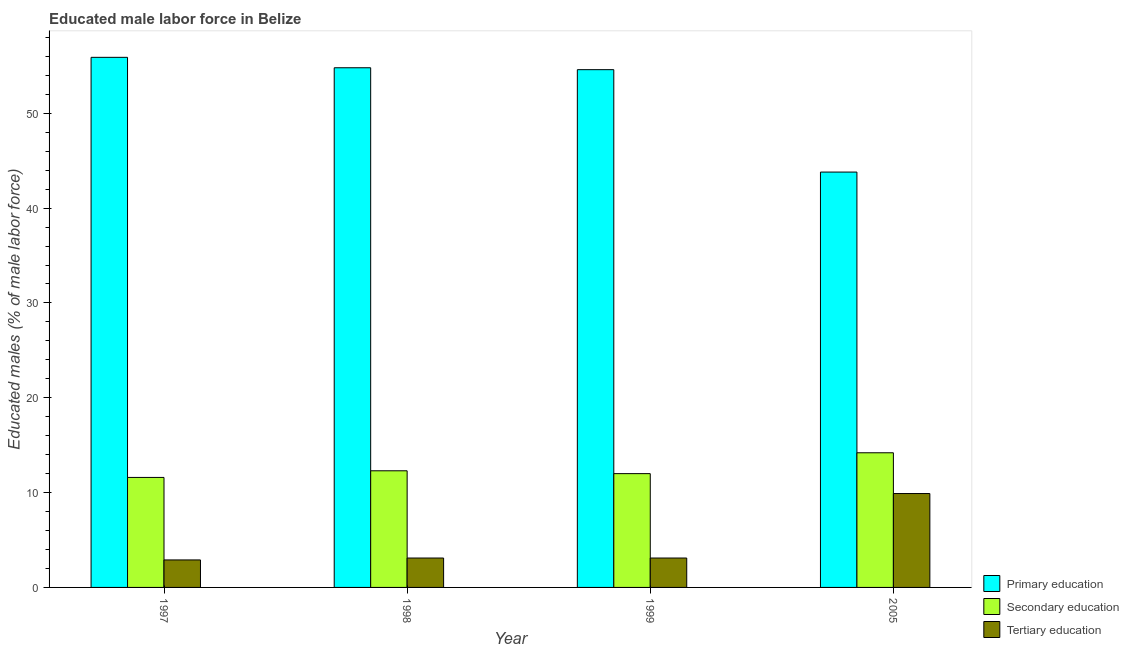How many different coloured bars are there?
Your answer should be very brief. 3. How many bars are there on the 2nd tick from the left?
Your answer should be compact. 3. How many bars are there on the 1st tick from the right?
Your response must be concise. 3. What is the label of the 3rd group of bars from the left?
Provide a succinct answer. 1999. What is the percentage of male labor force who received primary education in 1998?
Ensure brevity in your answer.  54.8. Across all years, what is the maximum percentage of male labor force who received secondary education?
Give a very brief answer. 14.2. Across all years, what is the minimum percentage of male labor force who received secondary education?
Offer a terse response. 11.6. In which year was the percentage of male labor force who received tertiary education maximum?
Give a very brief answer. 2005. What is the total percentage of male labor force who received secondary education in the graph?
Your response must be concise. 50.1. What is the difference between the percentage of male labor force who received primary education in 1998 and that in 1999?
Keep it short and to the point. 0.2. What is the difference between the percentage of male labor force who received tertiary education in 1997 and the percentage of male labor force who received primary education in 2005?
Provide a succinct answer. -7. What is the average percentage of male labor force who received tertiary education per year?
Provide a succinct answer. 4.75. In how many years, is the percentage of male labor force who received tertiary education greater than 16 %?
Provide a succinct answer. 0. What is the ratio of the percentage of male labor force who received secondary education in 1997 to that in 2005?
Make the answer very short. 0.82. Is the percentage of male labor force who received tertiary education in 1999 less than that in 2005?
Offer a terse response. Yes. Is the difference between the percentage of male labor force who received secondary education in 1998 and 1999 greater than the difference between the percentage of male labor force who received primary education in 1998 and 1999?
Ensure brevity in your answer.  No. What is the difference between the highest and the second highest percentage of male labor force who received tertiary education?
Your answer should be compact. 6.8. What is the difference between the highest and the lowest percentage of male labor force who received tertiary education?
Your answer should be compact. 7. In how many years, is the percentage of male labor force who received primary education greater than the average percentage of male labor force who received primary education taken over all years?
Your response must be concise. 3. Is the sum of the percentage of male labor force who received primary education in 1998 and 1999 greater than the maximum percentage of male labor force who received tertiary education across all years?
Make the answer very short. Yes. What does the 2nd bar from the left in 1997 represents?
Your answer should be very brief. Secondary education. What does the 1st bar from the right in 2005 represents?
Make the answer very short. Tertiary education. How many bars are there?
Offer a terse response. 12. Are all the bars in the graph horizontal?
Provide a short and direct response. No. Does the graph contain grids?
Ensure brevity in your answer.  No. How many legend labels are there?
Offer a terse response. 3. How are the legend labels stacked?
Your answer should be compact. Vertical. What is the title of the graph?
Your answer should be very brief. Educated male labor force in Belize. What is the label or title of the X-axis?
Give a very brief answer. Year. What is the label or title of the Y-axis?
Offer a very short reply. Educated males (% of male labor force). What is the Educated males (% of male labor force) in Primary education in 1997?
Your response must be concise. 55.9. What is the Educated males (% of male labor force) in Secondary education in 1997?
Offer a very short reply. 11.6. What is the Educated males (% of male labor force) in Tertiary education in 1997?
Offer a terse response. 2.9. What is the Educated males (% of male labor force) of Primary education in 1998?
Offer a terse response. 54.8. What is the Educated males (% of male labor force) in Secondary education in 1998?
Keep it short and to the point. 12.3. What is the Educated males (% of male labor force) in Tertiary education in 1998?
Provide a succinct answer. 3.1. What is the Educated males (% of male labor force) of Primary education in 1999?
Give a very brief answer. 54.6. What is the Educated males (% of male labor force) in Secondary education in 1999?
Your answer should be very brief. 12. What is the Educated males (% of male labor force) of Tertiary education in 1999?
Ensure brevity in your answer.  3.1. What is the Educated males (% of male labor force) in Primary education in 2005?
Keep it short and to the point. 43.8. What is the Educated males (% of male labor force) in Secondary education in 2005?
Provide a succinct answer. 14.2. What is the Educated males (% of male labor force) of Tertiary education in 2005?
Provide a succinct answer. 9.9. Across all years, what is the maximum Educated males (% of male labor force) of Primary education?
Your answer should be very brief. 55.9. Across all years, what is the maximum Educated males (% of male labor force) of Secondary education?
Offer a terse response. 14.2. Across all years, what is the maximum Educated males (% of male labor force) of Tertiary education?
Offer a terse response. 9.9. Across all years, what is the minimum Educated males (% of male labor force) of Primary education?
Offer a terse response. 43.8. Across all years, what is the minimum Educated males (% of male labor force) in Secondary education?
Keep it short and to the point. 11.6. Across all years, what is the minimum Educated males (% of male labor force) in Tertiary education?
Provide a short and direct response. 2.9. What is the total Educated males (% of male labor force) of Primary education in the graph?
Your response must be concise. 209.1. What is the total Educated males (% of male labor force) in Secondary education in the graph?
Your response must be concise. 50.1. What is the total Educated males (% of male labor force) of Tertiary education in the graph?
Make the answer very short. 19. What is the difference between the Educated males (% of male labor force) of Primary education in 1997 and that in 1998?
Make the answer very short. 1.1. What is the difference between the Educated males (% of male labor force) in Primary education in 1997 and that in 1999?
Offer a very short reply. 1.3. What is the difference between the Educated males (% of male labor force) of Secondary education in 1997 and that in 1999?
Offer a very short reply. -0.4. What is the difference between the Educated males (% of male labor force) of Tertiary education in 1997 and that in 1999?
Make the answer very short. -0.2. What is the difference between the Educated males (% of male labor force) in Tertiary education in 1997 and that in 2005?
Your answer should be compact. -7. What is the difference between the Educated males (% of male labor force) of Secondary education in 1998 and that in 1999?
Offer a terse response. 0.3. What is the difference between the Educated males (% of male labor force) in Secondary education in 1998 and that in 2005?
Offer a very short reply. -1.9. What is the difference between the Educated males (% of male labor force) in Primary education in 1999 and that in 2005?
Offer a very short reply. 10.8. What is the difference between the Educated males (% of male labor force) in Secondary education in 1999 and that in 2005?
Ensure brevity in your answer.  -2.2. What is the difference between the Educated males (% of male labor force) in Primary education in 1997 and the Educated males (% of male labor force) in Secondary education in 1998?
Your answer should be very brief. 43.6. What is the difference between the Educated males (% of male labor force) in Primary education in 1997 and the Educated males (% of male labor force) in Tertiary education in 1998?
Provide a short and direct response. 52.8. What is the difference between the Educated males (% of male labor force) in Secondary education in 1997 and the Educated males (% of male labor force) in Tertiary education in 1998?
Ensure brevity in your answer.  8.5. What is the difference between the Educated males (% of male labor force) of Primary education in 1997 and the Educated males (% of male labor force) of Secondary education in 1999?
Provide a short and direct response. 43.9. What is the difference between the Educated males (% of male labor force) of Primary education in 1997 and the Educated males (% of male labor force) of Tertiary education in 1999?
Offer a terse response. 52.8. What is the difference between the Educated males (% of male labor force) in Secondary education in 1997 and the Educated males (% of male labor force) in Tertiary education in 1999?
Your answer should be compact. 8.5. What is the difference between the Educated males (% of male labor force) in Primary education in 1997 and the Educated males (% of male labor force) in Secondary education in 2005?
Your answer should be compact. 41.7. What is the difference between the Educated males (% of male labor force) in Secondary education in 1997 and the Educated males (% of male labor force) in Tertiary education in 2005?
Offer a terse response. 1.7. What is the difference between the Educated males (% of male labor force) of Primary education in 1998 and the Educated males (% of male labor force) of Secondary education in 1999?
Your response must be concise. 42.8. What is the difference between the Educated males (% of male labor force) of Primary education in 1998 and the Educated males (% of male labor force) of Tertiary education in 1999?
Ensure brevity in your answer.  51.7. What is the difference between the Educated males (% of male labor force) in Primary education in 1998 and the Educated males (% of male labor force) in Secondary education in 2005?
Give a very brief answer. 40.6. What is the difference between the Educated males (% of male labor force) of Primary education in 1998 and the Educated males (% of male labor force) of Tertiary education in 2005?
Your response must be concise. 44.9. What is the difference between the Educated males (% of male labor force) of Secondary education in 1998 and the Educated males (% of male labor force) of Tertiary education in 2005?
Give a very brief answer. 2.4. What is the difference between the Educated males (% of male labor force) in Primary education in 1999 and the Educated males (% of male labor force) in Secondary education in 2005?
Offer a terse response. 40.4. What is the difference between the Educated males (% of male labor force) in Primary education in 1999 and the Educated males (% of male labor force) in Tertiary education in 2005?
Make the answer very short. 44.7. What is the difference between the Educated males (% of male labor force) in Secondary education in 1999 and the Educated males (% of male labor force) in Tertiary education in 2005?
Your answer should be compact. 2.1. What is the average Educated males (% of male labor force) in Primary education per year?
Provide a succinct answer. 52.27. What is the average Educated males (% of male labor force) in Secondary education per year?
Provide a succinct answer. 12.53. What is the average Educated males (% of male labor force) in Tertiary education per year?
Keep it short and to the point. 4.75. In the year 1997, what is the difference between the Educated males (% of male labor force) of Primary education and Educated males (% of male labor force) of Secondary education?
Provide a succinct answer. 44.3. In the year 1997, what is the difference between the Educated males (% of male labor force) of Secondary education and Educated males (% of male labor force) of Tertiary education?
Give a very brief answer. 8.7. In the year 1998, what is the difference between the Educated males (% of male labor force) of Primary education and Educated males (% of male labor force) of Secondary education?
Give a very brief answer. 42.5. In the year 1998, what is the difference between the Educated males (% of male labor force) of Primary education and Educated males (% of male labor force) of Tertiary education?
Ensure brevity in your answer.  51.7. In the year 1999, what is the difference between the Educated males (% of male labor force) of Primary education and Educated males (% of male labor force) of Secondary education?
Provide a succinct answer. 42.6. In the year 1999, what is the difference between the Educated males (% of male labor force) in Primary education and Educated males (% of male labor force) in Tertiary education?
Offer a terse response. 51.5. In the year 1999, what is the difference between the Educated males (% of male labor force) in Secondary education and Educated males (% of male labor force) in Tertiary education?
Ensure brevity in your answer.  8.9. In the year 2005, what is the difference between the Educated males (% of male labor force) in Primary education and Educated males (% of male labor force) in Secondary education?
Provide a succinct answer. 29.6. In the year 2005, what is the difference between the Educated males (% of male labor force) in Primary education and Educated males (% of male labor force) in Tertiary education?
Ensure brevity in your answer.  33.9. What is the ratio of the Educated males (% of male labor force) of Primary education in 1997 to that in 1998?
Your response must be concise. 1.02. What is the ratio of the Educated males (% of male labor force) in Secondary education in 1997 to that in 1998?
Your response must be concise. 0.94. What is the ratio of the Educated males (% of male labor force) of Tertiary education in 1997 to that in 1998?
Offer a very short reply. 0.94. What is the ratio of the Educated males (% of male labor force) in Primary education in 1997 to that in 1999?
Provide a succinct answer. 1.02. What is the ratio of the Educated males (% of male labor force) in Secondary education in 1997 to that in 1999?
Give a very brief answer. 0.97. What is the ratio of the Educated males (% of male labor force) in Tertiary education in 1997 to that in 1999?
Provide a short and direct response. 0.94. What is the ratio of the Educated males (% of male labor force) in Primary education in 1997 to that in 2005?
Ensure brevity in your answer.  1.28. What is the ratio of the Educated males (% of male labor force) of Secondary education in 1997 to that in 2005?
Provide a succinct answer. 0.82. What is the ratio of the Educated males (% of male labor force) of Tertiary education in 1997 to that in 2005?
Offer a terse response. 0.29. What is the ratio of the Educated males (% of male labor force) in Primary education in 1998 to that in 1999?
Offer a very short reply. 1. What is the ratio of the Educated males (% of male labor force) of Tertiary education in 1998 to that in 1999?
Offer a terse response. 1. What is the ratio of the Educated males (% of male labor force) in Primary education in 1998 to that in 2005?
Provide a short and direct response. 1.25. What is the ratio of the Educated males (% of male labor force) of Secondary education in 1998 to that in 2005?
Offer a very short reply. 0.87. What is the ratio of the Educated males (% of male labor force) in Tertiary education in 1998 to that in 2005?
Your answer should be very brief. 0.31. What is the ratio of the Educated males (% of male labor force) in Primary education in 1999 to that in 2005?
Your answer should be compact. 1.25. What is the ratio of the Educated males (% of male labor force) of Secondary education in 1999 to that in 2005?
Provide a succinct answer. 0.85. What is the ratio of the Educated males (% of male labor force) of Tertiary education in 1999 to that in 2005?
Your answer should be very brief. 0.31. What is the difference between the highest and the second highest Educated males (% of male labor force) in Primary education?
Ensure brevity in your answer.  1.1. What is the difference between the highest and the second highest Educated males (% of male labor force) in Secondary education?
Your answer should be compact. 1.9. What is the difference between the highest and the second highest Educated males (% of male labor force) of Tertiary education?
Your response must be concise. 6.8. What is the difference between the highest and the lowest Educated males (% of male labor force) in Primary education?
Your answer should be compact. 12.1. 